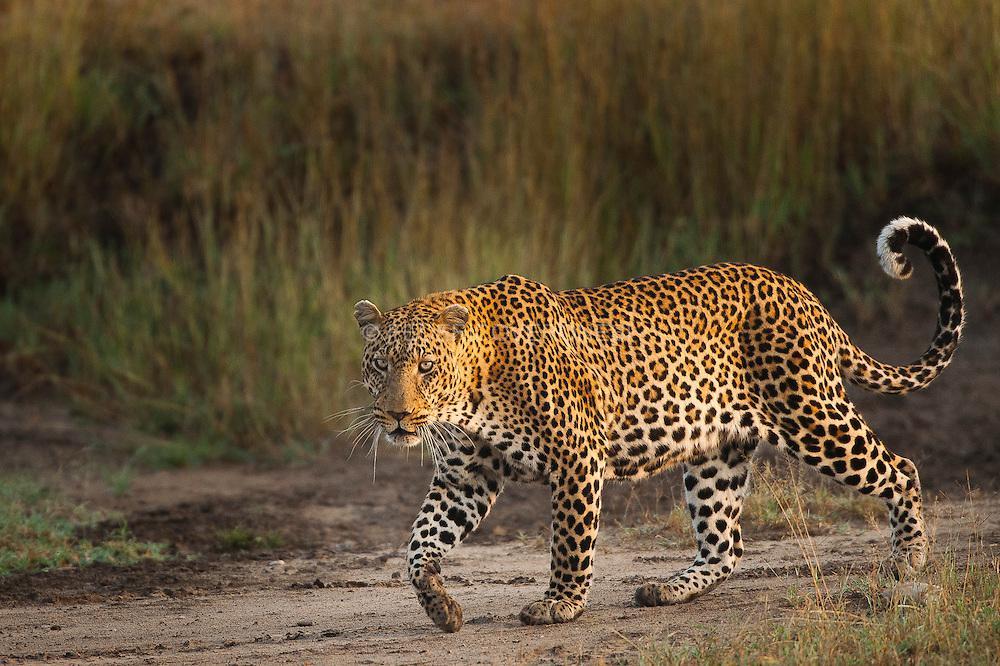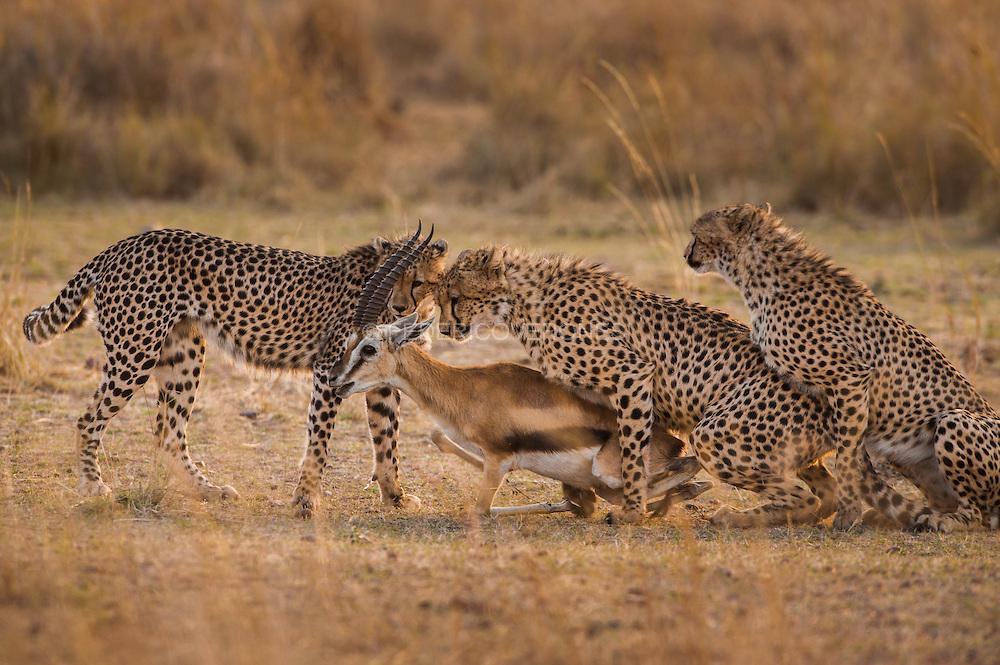The first image is the image on the left, the second image is the image on the right. Considering the images on both sides, is "In one image there is a single cheetah and in the other there is a single cheetah successfully hunting an antelope." valid? Answer yes or no. No. 